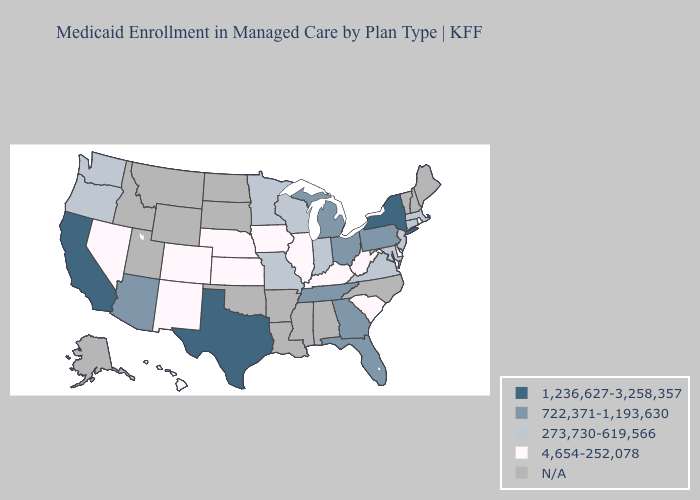Name the states that have a value in the range N/A?
Write a very short answer. Alabama, Alaska, Arkansas, Idaho, Louisiana, Maine, Mississippi, Montana, New Hampshire, North Carolina, North Dakota, Oklahoma, South Dakota, Utah, Vermont, Wyoming. Does California have the lowest value in the USA?
Keep it brief. No. Name the states that have a value in the range 722,371-1,193,630?
Write a very short answer. Arizona, Florida, Georgia, Michigan, Ohio, Pennsylvania, Tennessee. What is the value of North Dakota?
Keep it brief. N/A. What is the lowest value in the USA?
Give a very brief answer. 4,654-252,078. Which states have the lowest value in the USA?
Be succinct. Colorado, Delaware, Hawaii, Illinois, Iowa, Kansas, Kentucky, Nebraska, Nevada, New Mexico, Rhode Island, South Carolina, West Virginia. Among the states that border Florida , which have the highest value?
Be succinct. Georgia. Does New Jersey have the lowest value in the Northeast?
Give a very brief answer. No. Does the first symbol in the legend represent the smallest category?
Write a very short answer. No. Does New York have the highest value in the USA?
Quick response, please. Yes. Among the states that border Idaho , which have the lowest value?
Keep it brief. Nevada. Is the legend a continuous bar?
Answer briefly. No. Name the states that have a value in the range 273,730-619,566?
Write a very short answer. Connecticut, Indiana, Maryland, Massachusetts, Minnesota, Missouri, New Jersey, Oregon, Virginia, Washington, Wisconsin. Among the states that border Minnesota , which have the highest value?
Give a very brief answer. Wisconsin. Name the states that have a value in the range 722,371-1,193,630?
Give a very brief answer. Arizona, Florida, Georgia, Michigan, Ohio, Pennsylvania, Tennessee. 